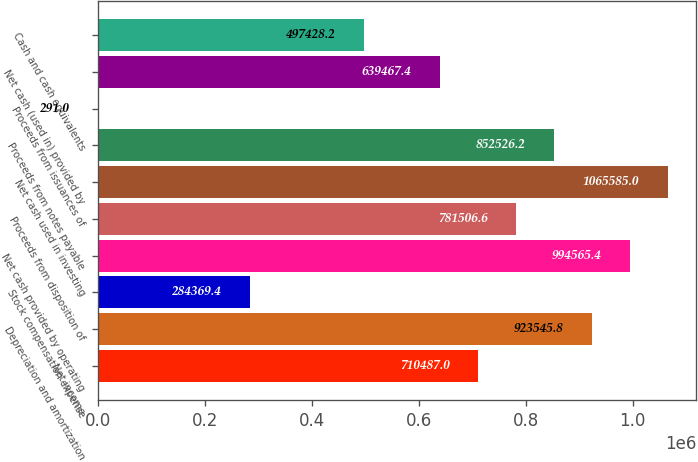Convert chart to OTSL. <chart><loc_0><loc_0><loc_500><loc_500><bar_chart><fcel>Net income<fcel>Depreciation and amortization<fcel>Stock compensation expense<fcel>Net cash provided by operating<fcel>Proceeds from disposition of<fcel>Net cash used in investing<fcel>Proceeds from notes payable<fcel>Proceeds from issuances of<fcel>Net cash (used in) provided by<fcel>Cash and cash equivalents<nl><fcel>710487<fcel>923546<fcel>284369<fcel>994565<fcel>781507<fcel>1.06558e+06<fcel>852526<fcel>291<fcel>639467<fcel>497428<nl></chart> 